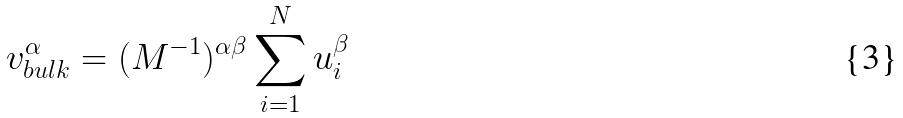<formula> <loc_0><loc_0><loc_500><loc_500>v _ { b u l k } ^ { \alpha } = ( M ^ { - 1 } ) ^ { \alpha \beta } \sum _ { i = 1 } ^ { N } u _ { i } ^ { \beta }</formula> 